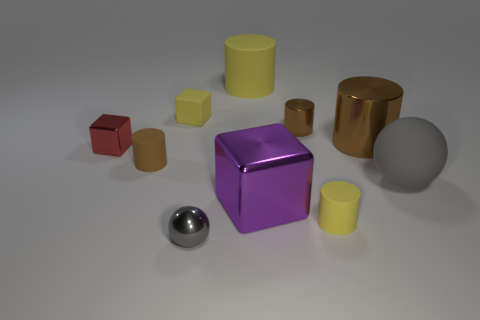There is a large object that is the same color as the rubber cube; what material is it?
Provide a short and direct response. Rubber. There is a cylinder in front of the purple cube; is its color the same as the large cylinder to the left of the big brown cylinder?
Your response must be concise. Yes. What shape is the big metallic thing in front of the red metal cube?
Offer a terse response. Cube. What size is the yellow cylinder on the right side of the large rubber thing behind the metal cube behind the tiny brown matte cylinder?
Offer a terse response. Small. What number of small brown rubber cylinders are right of the matte cylinder that is on the left side of the small gray metallic thing?
Offer a terse response. 0. There is a brown cylinder that is both to the right of the big yellow cylinder and in front of the small brown metallic cylinder; what size is it?
Your answer should be compact. Large. What number of shiny things are either brown objects or large brown cylinders?
Provide a short and direct response. 2. What is the large yellow cylinder made of?
Keep it short and to the point. Rubber. The tiny brown object behind the matte cylinder to the left of the gray thing to the left of the large shiny cylinder is made of what material?
Ensure brevity in your answer.  Metal. What is the shape of the brown shiny thing that is the same size as the red object?
Keep it short and to the point. Cylinder. 